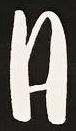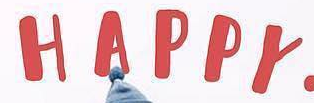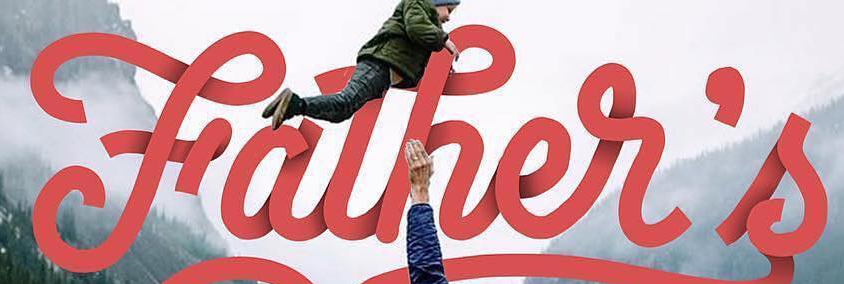What words are shown in these images in order, separated by a semicolon? A; HAPPY; Father's 